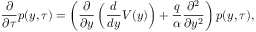<formula> <loc_0><loc_0><loc_500><loc_500>\frac { \partial } { \partial \tau } p ( y , \tau ) = \left ( \frac { \partial } { \partial y } \left ( \frac { d } { d y } V ( y ) \right ) + \frac { q } { \alpha } \frac { \partial ^ { 2 } } { \partial y ^ { 2 } } \right ) p ( y , \tau ) ,</formula> 